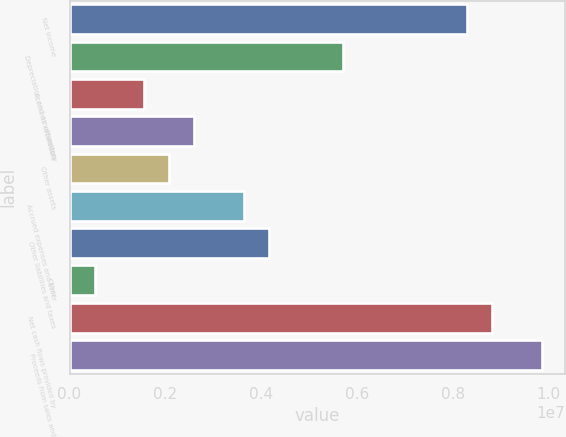<chart> <loc_0><loc_0><loc_500><loc_500><bar_chart><fcel>Net income<fcel>Depreciation and amortization<fcel>Accounts receivable<fcel>Inventory<fcel>Other assets<fcel>Accrued expenses and other<fcel>Other liabilities and taxes<fcel>Other<fcel>Net cash flows provided by<fcel>Proceeds from sales and<nl><fcel>8.29931e+06<fcel>5.70826e+06<fcel>1.56259e+06<fcel>2.59901e+06<fcel>2.0808e+06<fcel>3.63542e+06<fcel>4.15363e+06<fcel>526168<fcel>8.81752e+06<fcel>9.85394e+06<nl></chart> 